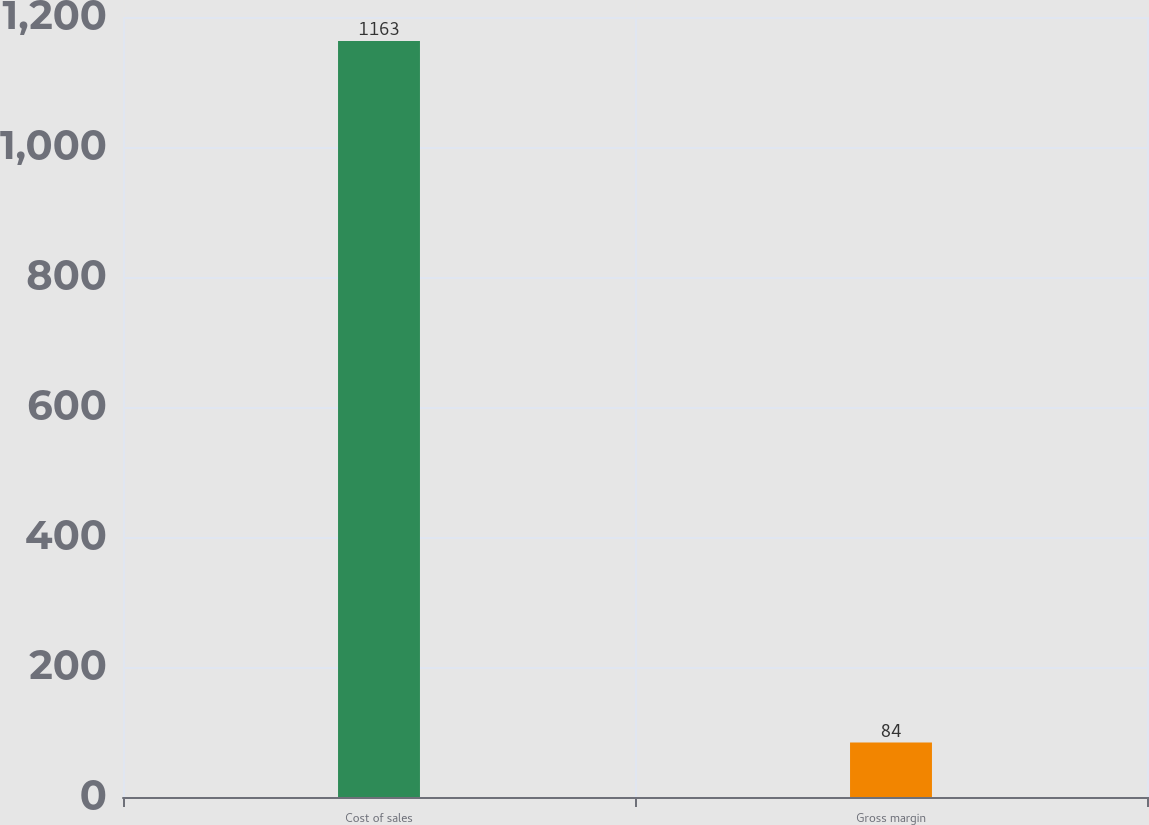Convert chart. <chart><loc_0><loc_0><loc_500><loc_500><bar_chart><fcel>Cost of sales<fcel>Gross margin<nl><fcel>1163<fcel>84<nl></chart> 